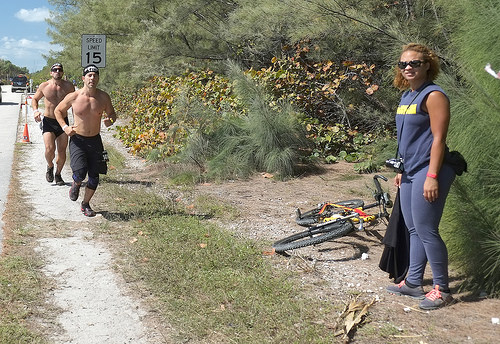<image>
Is there a bike behind the woman? Yes. From this viewpoint, the bike is positioned behind the woman, with the woman partially or fully occluding the bike. 